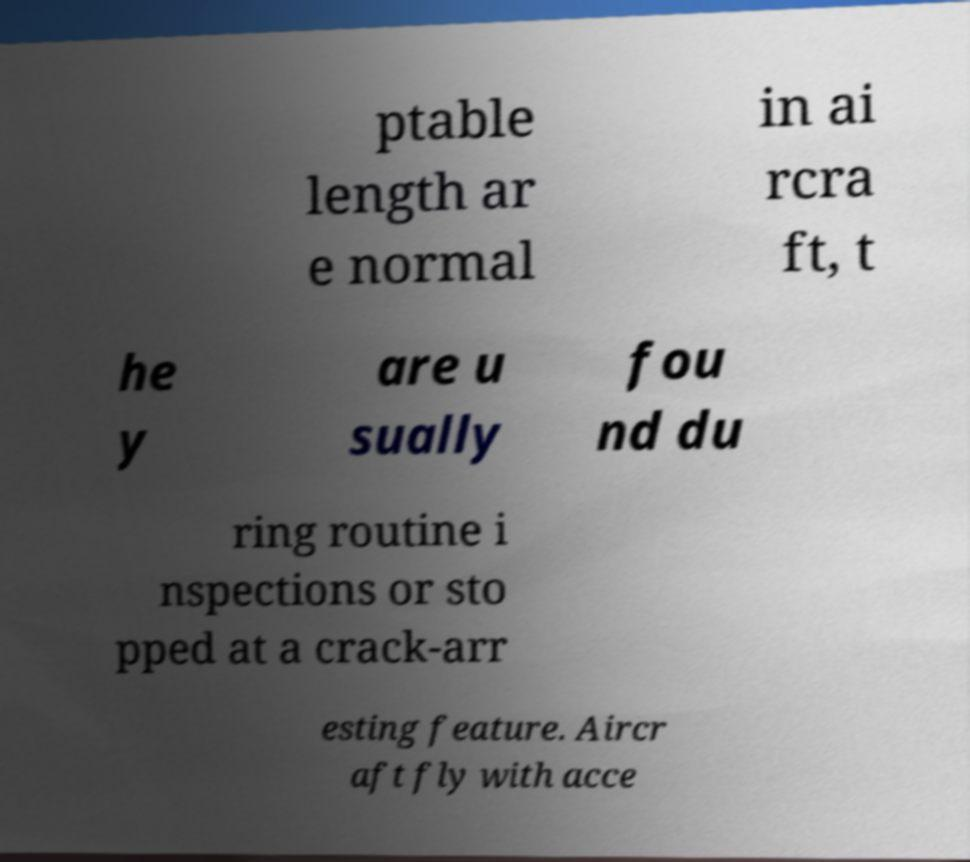There's text embedded in this image that I need extracted. Can you transcribe it verbatim? ptable length ar e normal in ai rcra ft, t he y are u sually fou nd du ring routine i nspections or sto pped at a crack-arr esting feature. Aircr aft fly with acce 